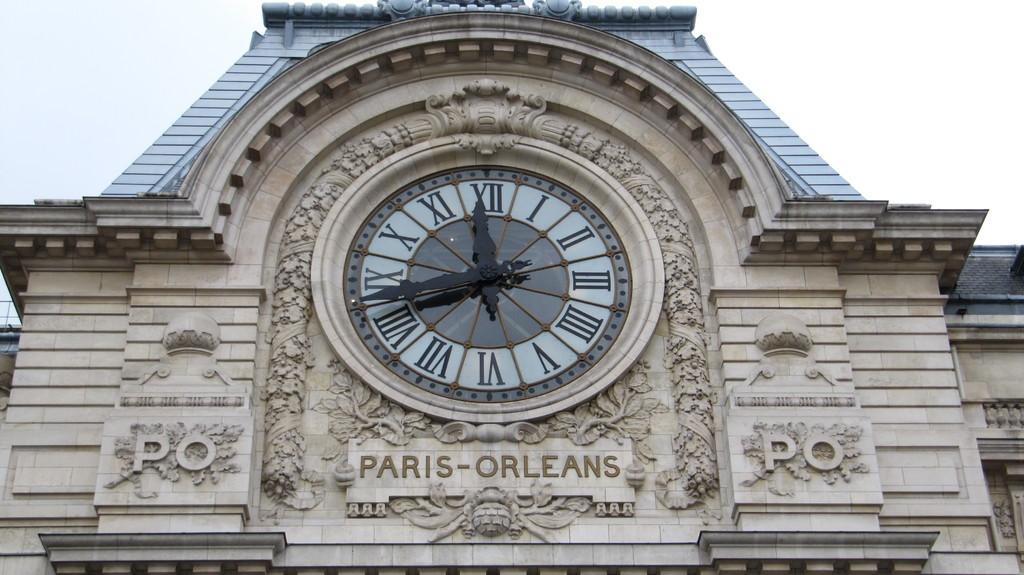<image>
Give a short and clear explanation of the subsequent image. An intricately carved clock that says Paris-Orleans on the bottom of it. 